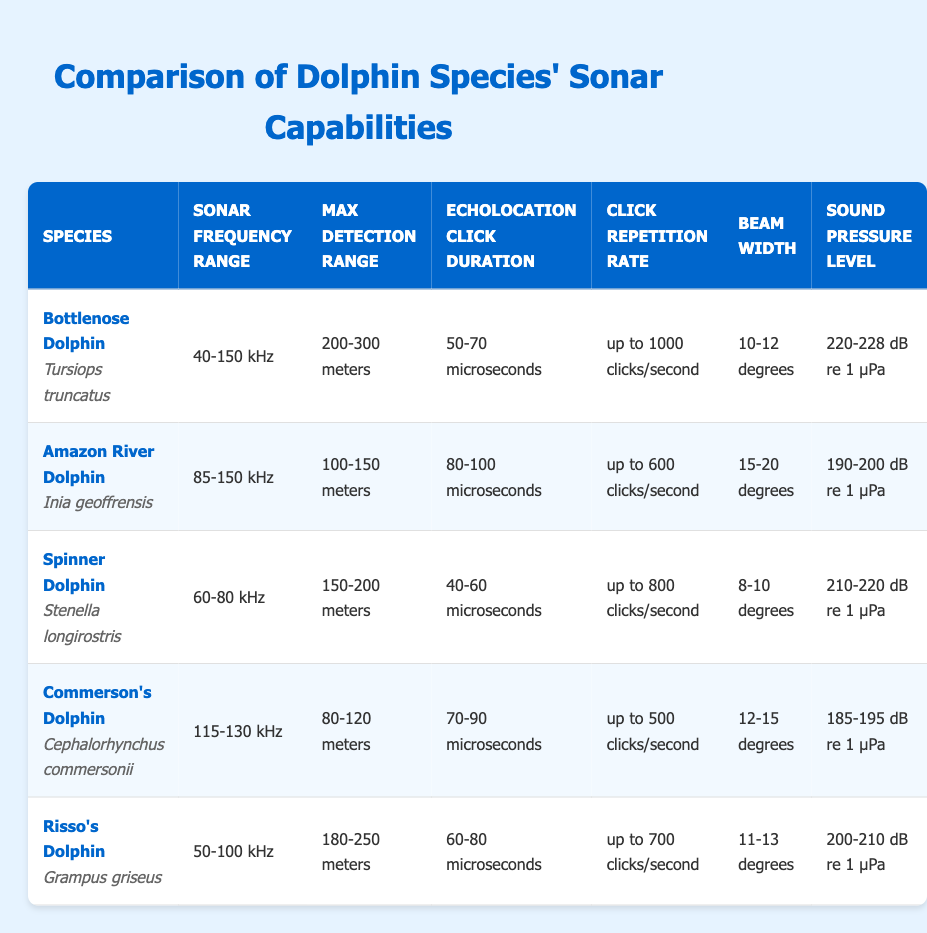What is the sonar frequency range of the Bottlenose Dolphin? From the table, the Bottlenose Dolphin is listed with a sonar frequency range of 40-150 kHz.
Answer: 40-150 kHz Which dolphin species has the highest sound pressure level? According to the table, the Bottlenose Dolphin has a sound pressure level of 220-228 dB re 1 μPa, which is the highest among all listed species.
Answer: Bottlenose Dolphin What is the average maximum detection range of all dolphin species listed? The maximum detection ranges are: Bottlenose Dolphin (200-300 meters), Amazon River Dolphin (100-150 meters), Spinner Dolphin (150-200 meters), Commerson's Dolphin (80-120 meters), and Risso's Dolphin (180-250 meters). Taking the average of these ranges: (250 + 125 + 175 + 100 + 215)/5 = 171 meters (using averages of each range).
Answer: 171 meters True or False: The Echolocation Click Duration for the Amazon River Dolphin is less than that of the Commerson's Dolphin. The table shows that the Echolocation Click Duration for the Amazon River Dolphin is 80-100 microseconds, while for the Commerson's Dolphin, it is 70-90 microseconds. Therefore, this statement is false.
Answer: False Which dolphin species has the widest beam width? Looking at the beam widths in the table: Bottlenose Dolphin (10-12 degrees), Amazon River Dolphin (15-20 degrees), Spinner Dolphin (8-10 degrees), Commerson's Dolphin (12-15 degrees), and Risso's Dolphin (11-13 degrees). The Amazon River Dolphin has the widest beam width of 15-20 degrees.
Answer: Amazon River Dolphin If you were to combine the click repetition rate of the Bottlenose and Risso's Dolphin, what would the total number of clicks be? The click repetition rates are: Bottlenose Dolphin (up to 1000 clicks/second) and Risso's Dolphin (up to 700 clicks/second). Adding them together gives: 1000 + 700 = 1700 clicks/second.
Answer: 1700 clicks/second Which species has a sonar frequency range below 100 kHz, and what is that range? From the table, the species with a sonar frequency range below 100 kHz is the Spinner Dolphin with a range of 60-80 kHz and the Risso's Dolphin with a range of 50-100 kHz.
Answer: Spinner Dolphin 60-80 kHz, Risso's Dolphin 50-100 kHz What is the difference in the maximum detection range between the highest and lowest species? The maximum detection range is highest for Bottlenose Dolphin (300 meters) and lowest for Commerson's Dolphin (120 meters). The difference is 300 - 120 = 180 meters.
Answer: 180 meters True or False: The click repetition rate of the Commerson's Dolphin exceeds 600 clicks/second. According to the table, the Commerson's Dolphin has a click repetition rate of up to 500 clicks/second, which does not exceed 600 clicks/second. Therefore, the statement is false.
Answer: False 